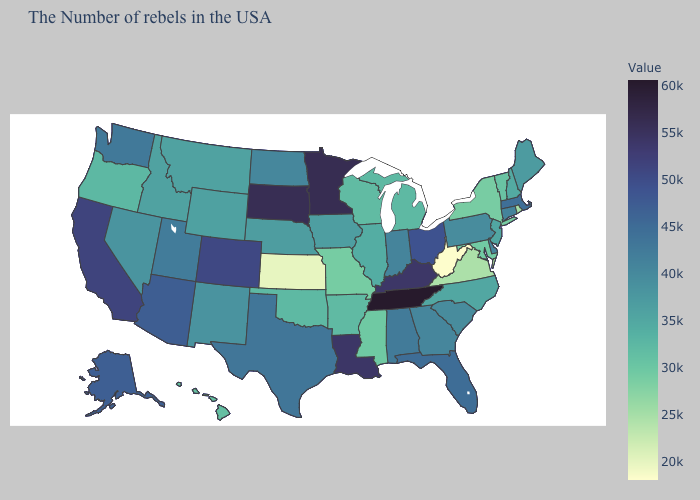Does Montana have the highest value in the USA?
Quick response, please. No. Does West Virginia have the highest value in the USA?
Quick response, please. No. Is the legend a continuous bar?
Write a very short answer. Yes. Which states have the lowest value in the USA?
Write a very short answer. West Virginia. Is the legend a continuous bar?
Write a very short answer. Yes. Does Hawaii have the lowest value in the West?
Keep it brief. Yes. Among the states that border Oregon , does California have the highest value?
Keep it brief. Yes. 